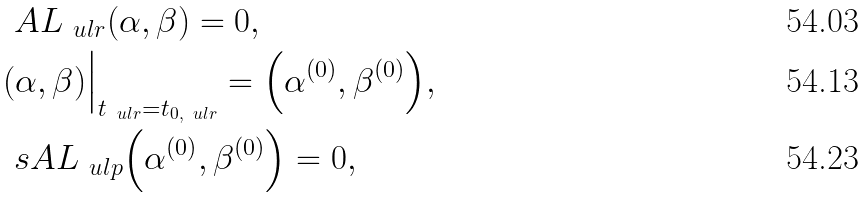<formula> <loc_0><loc_0><loc_500><loc_500>& \ A L _ { \ u l r } ( \alpha , \beta ) = 0 , \\ & ( \alpha , \beta ) \Big | _ { t _ { \ u l r } = t _ { 0 , \ u l r } } = \Big ( \alpha ^ { ( 0 ) } , \beta ^ { ( 0 ) } \Big ) , \\ & \ s A L _ { \ u l p } \Big ( \alpha ^ { ( 0 ) } , \beta ^ { ( 0 ) } \Big ) = 0 ,</formula> 